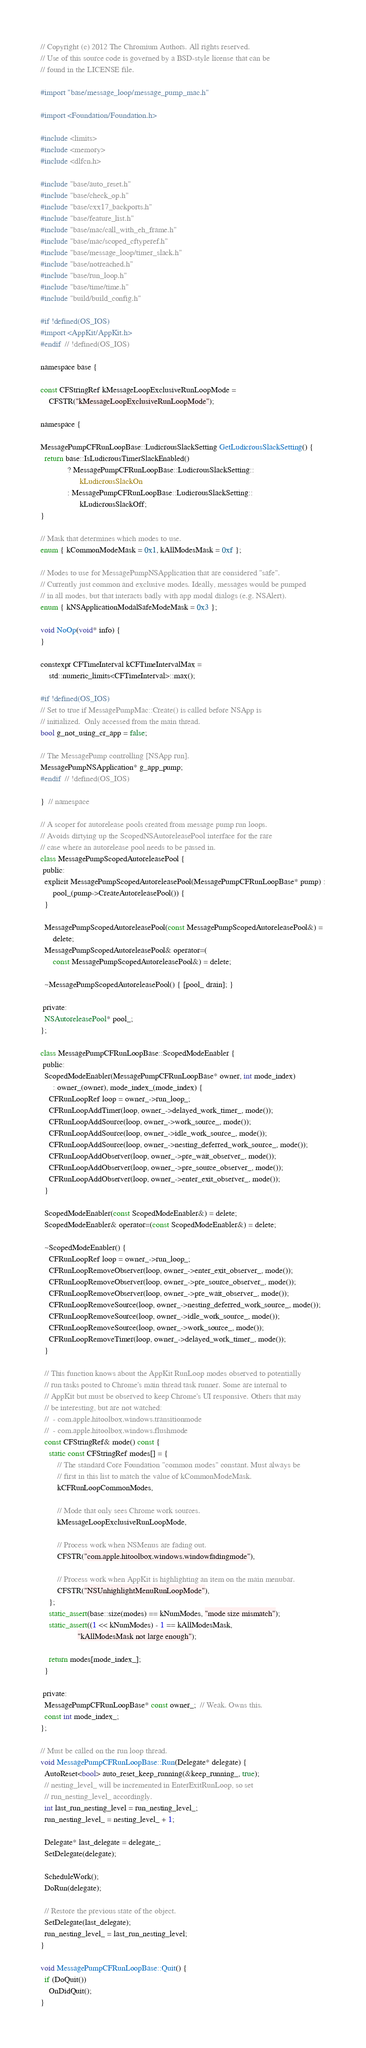<code> <loc_0><loc_0><loc_500><loc_500><_ObjectiveC_>// Copyright (c) 2012 The Chromium Authors. All rights reserved.
// Use of this source code is governed by a BSD-style license that can be
// found in the LICENSE file.

#import "base/message_loop/message_pump_mac.h"

#import <Foundation/Foundation.h>

#include <limits>
#include <memory>
#include <dlfcn.h>

#include "base/auto_reset.h"
#include "base/check_op.h"
#include "base/cxx17_backports.h"
#include "base/feature_list.h"
#include "base/mac/call_with_eh_frame.h"
#include "base/mac/scoped_cftyperef.h"
#include "base/message_loop/timer_slack.h"
#include "base/notreached.h"
#include "base/run_loop.h"
#include "base/time/time.h"
#include "build/build_config.h"

#if !defined(OS_IOS)
#import <AppKit/AppKit.h>
#endif  // !defined(OS_IOS)

namespace base {

const CFStringRef kMessageLoopExclusiveRunLoopMode =
    CFSTR("kMessageLoopExclusiveRunLoopMode");

namespace {

MessagePumpCFRunLoopBase::LudicrousSlackSetting GetLudicrousSlackSetting() {
  return base::IsLudicrousTimerSlackEnabled()
             ? MessagePumpCFRunLoopBase::LudicrousSlackSetting::
                   kLudicrousSlackOn
             : MessagePumpCFRunLoopBase::LudicrousSlackSetting::
                   kLudicrousSlackOff;
}

// Mask that determines which modes to use.
enum { kCommonModeMask = 0x1, kAllModesMask = 0xf };

// Modes to use for MessagePumpNSApplication that are considered "safe".
// Currently just common and exclusive modes. Ideally, messages would be pumped
// in all modes, but that interacts badly with app modal dialogs (e.g. NSAlert).
enum { kNSApplicationModalSafeModeMask = 0x3 };

void NoOp(void* info) {
}

constexpr CFTimeInterval kCFTimeIntervalMax =
    std::numeric_limits<CFTimeInterval>::max();

#if !defined(OS_IOS)
// Set to true if MessagePumpMac::Create() is called before NSApp is
// initialized.  Only accessed from the main thread.
bool g_not_using_cr_app = false;

// The MessagePump controlling [NSApp run].
MessagePumpNSApplication* g_app_pump;
#endif  // !defined(OS_IOS)

}  // namespace

// A scoper for autorelease pools created from message pump run loops.
// Avoids dirtying up the ScopedNSAutoreleasePool interface for the rare
// case where an autorelease pool needs to be passed in.
class MessagePumpScopedAutoreleasePool {
 public:
  explicit MessagePumpScopedAutoreleasePool(MessagePumpCFRunLoopBase* pump) :
      pool_(pump->CreateAutoreleasePool()) {
  }

  MessagePumpScopedAutoreleasePool(const MessagePumpScopedAutoreleasePool&) =
      delete;
  MessagePumpScopedAutoreleasePool& operator=(
      const MessagePumpScopedAutoreleasePool&) = delete;

  ~MessagePumpScopedAutoreleasePool() { [pool_ drain]; }

 private:
  NSAutoreleasePool* pool_;
};

class MessagePumpCFRunLoopBase::ScopedModeEnabler {
 public:
  ScopedModeEnabler(MessagePumpCFRunLoopBase* owner, int mode_index)
      : owner_(owner), mode_index_(mode_index) {
    CFRunLoopRef loop = owner_->run_loop_;
    CFRunLoopAddTimer(loop, owner_->delayed_work_timer_, mode());
    CFRunLoopAddSource(loop, owner_->work_source_, mode());
    CFRunLoopAddSource(loop, owner_->idle_work_source_, mode());
    CFRunLoopAddSource(loop, owner_->nesting_deferred_work_source_, mode());
    CFRunLoopAddObserver(loop, owner_->pre_wait_observer_, mode());
    CFRunLoopAddObserver(loop, owner_->pre_source_observer_, mode());
    CFRunLoopAddObserver(loop, owner_->enter_exit_observer_, mode());
  }

  ScopedModeEnabler(const ScopedModeEnabler&) = delete;
  ScopedModeEnabler& operator=(const ScopedModeEnabler&) = delete;

  ~ScopedModeEnabler() {
    CFRunLoopRef loop = owner_->run_loop_;
    CFRunLoopRemoveObserver(loop, owner_->enter_exit_observer_, mode());
    CFRunLoopRemoveObserver(loop, owner_->pre_source_observer_, mode());
    CFRunLoopRemoveObserver(loop, owner_->pre_wait_observer_, mode());
    CFRunLoopRemoveSource(loop, owner_->nesting_deferred_work_source_, mode());
    CFRunLoopRemoveSource(loop, owner_->idle_work_source_, mode());
    CFRunLoopRemoveSource(loop, owner_->work_source_, mode());
    CFRunLoopRemoveTimer(loop, owner_->delayed_work_timer_, mode());
  }

  // This function knows about the AppKit RunLoop modes observed to potentially
  // run tasks posted to Chrome's main thread task runner. Some are internal to
  // AppKit but must be observed to keep Chrome's UI responsive. Others that may
  // be interesting, but are not watched:
  //  - com.apple.hitoolbox.windows.transitionmode
  //  - com.apple.hitoolbox.windows.flushmode
  const CFStringRef& mode() const {
    static const CFStringRef modes[] = {
        // The standard Core Foundation "common modes" constant. Must always be
        // first in this list to match the value of kCommonModeMask.
        kCFRunLoopCommonModes,

        // Mode that only sees Chrome work sources.
        kMessageLoopExclusiveRunLoopMode,

        // Process work when NSMenus are fading out.
        CFSTR("com.apple.hitoolbox.windows.windowfadingmode"),

        // Process work when AppKit is highlighting an item on the main menubar.
        CFSTR("NSUnhighlightMenuRunLoopMode"),
    };
    static_assert(base::size(modes) == kNumModes, "mode size mismatch");
    static_assert((1 << kNumModes) - 1 == kAllModesMask,
                  "kAllModesMask not large enough");

    return modes[mode_index_];
  }

 private:
  MessagePumpCFRunLoopBase* const owner_;  // Weak. Owns this.
  const int mode_index_;
};

// Must be called on the run loop thread.
void MessagePumpCFRunLoopBase::Run(Delegate* delegate) {
  AutoReset<bool> auto_reset_keep_running(&keep_running_, true);
  // nesting_level_ will be incremented in EnterExitRunLoop, so set
  // run_nesting_level_ accordingly.
  int last_run_nesting_level = run_nesting_level_;
  run_nesting_level_ = nesting_level_ + 1;

  Delegate* last_delegate = delegate_;
  SetDelegate(delegate);

  ScheduleWork();
  DoRun(delegate);

  // Restore the previous state of the object.
  SetDelegate(last_delegate);
  run_nesting_level_ = last_run_nesting_level;
}

void MessagePumpCFRunLoopBase::Quit() {
  if (DoQuit())
    OnDidQuit();
}
</code> 